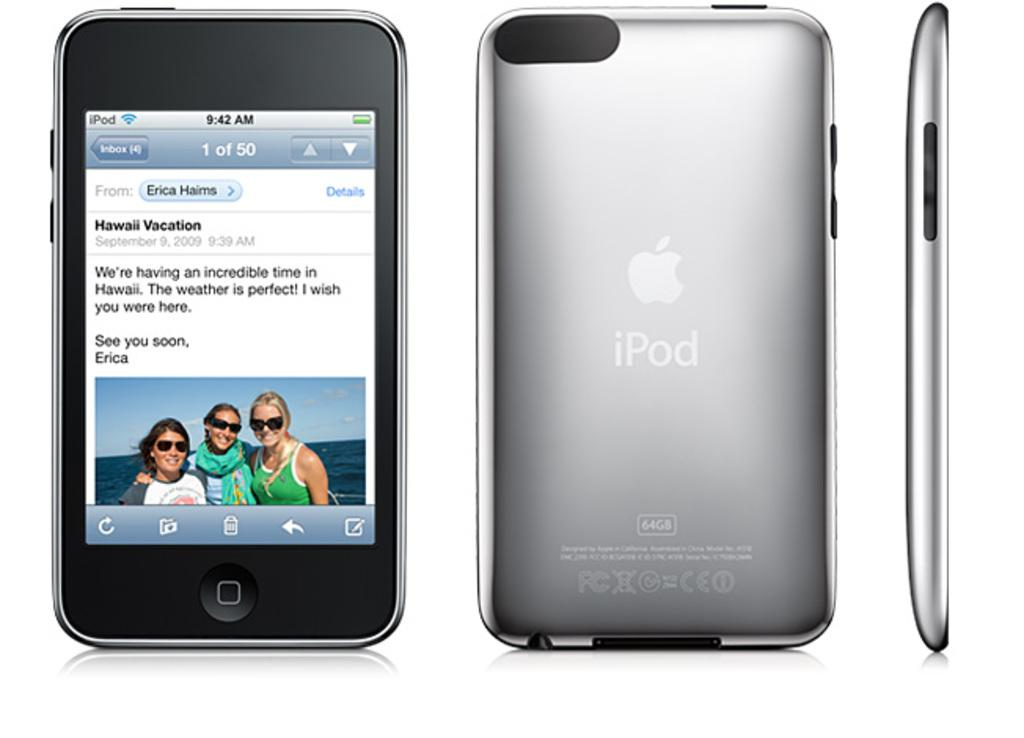What type of device is shown in the image? The image shows an iPod. How many different views of the iPod are visible in the image? There are three different views of the iPod in the image: a front view, a back view, and a side view. Can you describe the front view of the iPod? The front view of the iPod shows the screen and the buttons. What type of brush is used to clean the iPod in the image? There is no brush visible in the image, and the iPod is not being cleaned. 